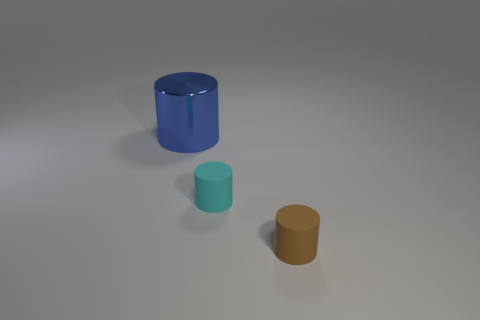What number of balls are either small brown things or metal objects?
Make the answer very short. 0. There is a small rubber object that is right of the small cyan cylinder; what color is it?
Make the answer very short. Brown. How many rubber objects are large blue things or cyan cylinders?
Ensure brevity in your answer.  1. There is a blue object behind the tiny matte object that is to the right of the tiny cyan matte cylinder; what is its material?
Keep it short and to the point. Metal. What color is the metallic cylinder?
Make the answer very short. Blue. There is a small matte cylinder left of the brown rubber cylinder; is there a cyan matte cylinder that is behind it?
Offer a very short reply. No. What material is the tiny cyan cylinder?
Provide a succinct answer. Rubber. Do the tiny object on the left side of the tiny brown cylinder and the cylinder that is behind the tiny cyan matte cylinder have the same material?
Offer a very short reply. No. Is there any other thing of the same color as the big metallic cylinder?
Provide a short and direct response. No. What color is the other small matte thing that is the same shape as the tiny cyan matte thing?
Provide a succinct answer. Brown. 